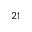Convert formula to latex. <formula><loc_0><loc_0><loc_500><loc_500>2 1</formula> 